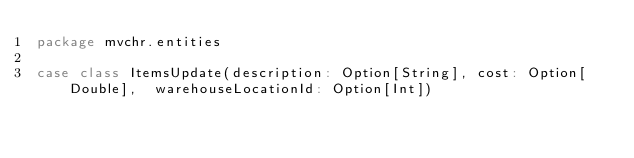Convert code to text. <code><loc_0><loc_0><loc_500><loc_500><_Scala_>package mvchr.entities

case class ItemsUpdate(description: Option[String], cost: Option[Double],  warehouseLocationId: Option[Int])
</code> 